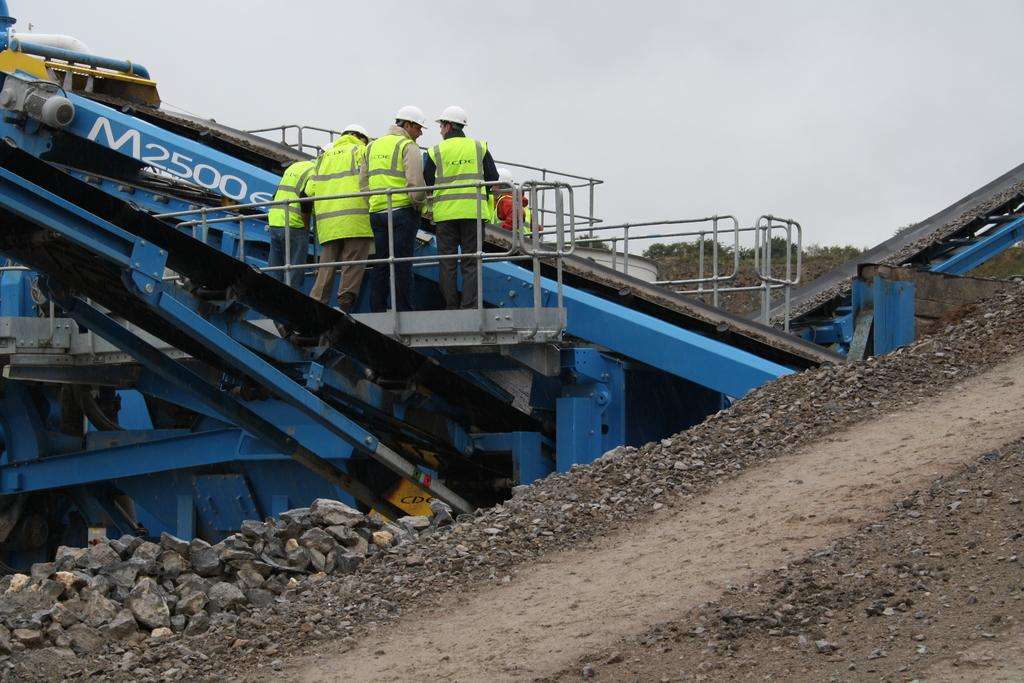<image>
Describe the image concisely. 4 men standing in front of a blue M25000 conveyor belt. 